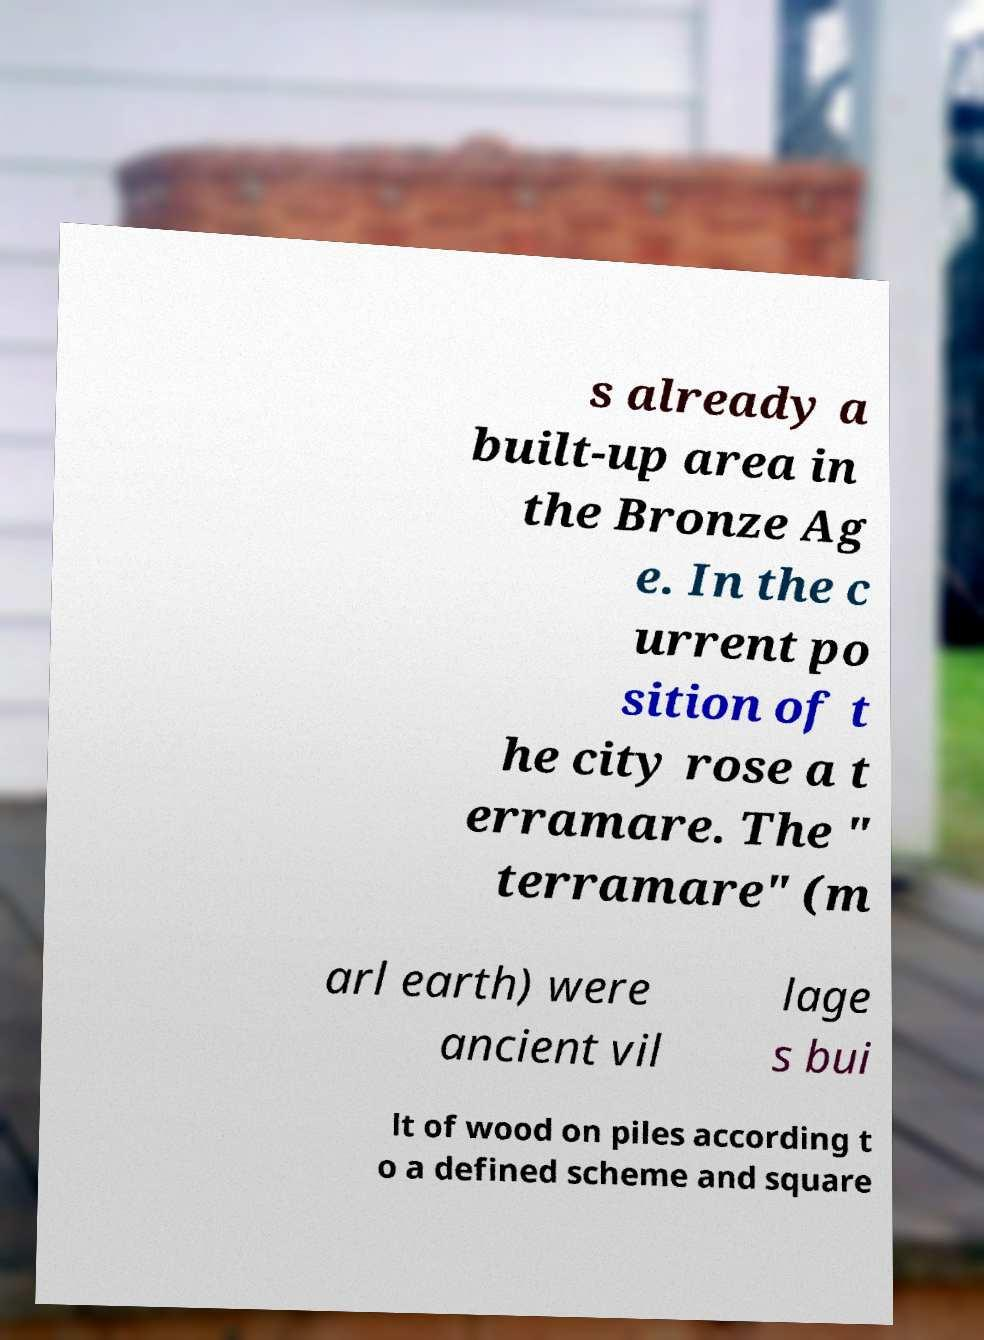Please read and relay the text visible in this image. What does it say? s already a built-up area in the Bronze Ag e. In the c urrent po sition of t he city rose a t erramare. The " terramare" (m arl earth) were ancient vil lage s bui lt of wood on piles according t o a defined scheme and square 